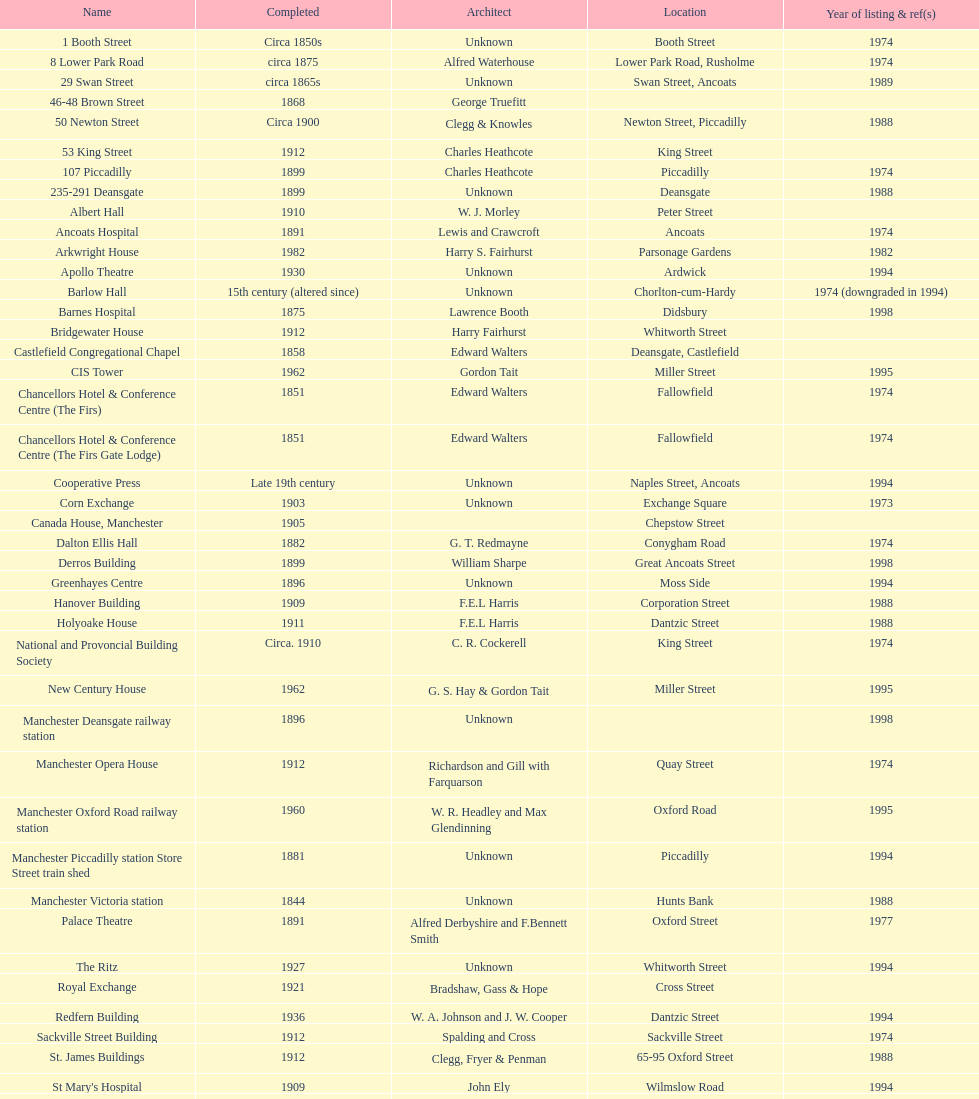In 1974, how many buildings were listed as having the same year? 15. 